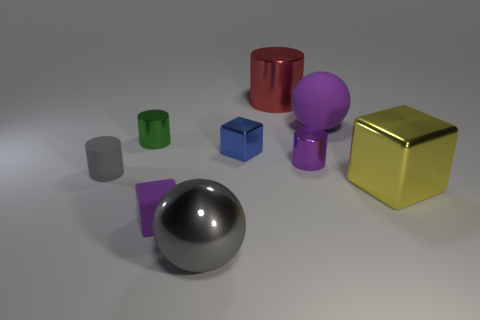Subtract 1 cylinders. How many cylinders are left? 3 Add 1 large metal things. How many objects exist? 10 Subtract all cubes. How many objects are left? 6 Subtract 0 cyan blocks. How many objects are left? 9 Subtract all small matte things. Subtract all gray spheres. How many objects are left? 6 Add 6 large red cylinders. How many large red cylinders are left? 7 Add 1 yellow metallic blocks. How many yellow metallic blocks exist? 2 